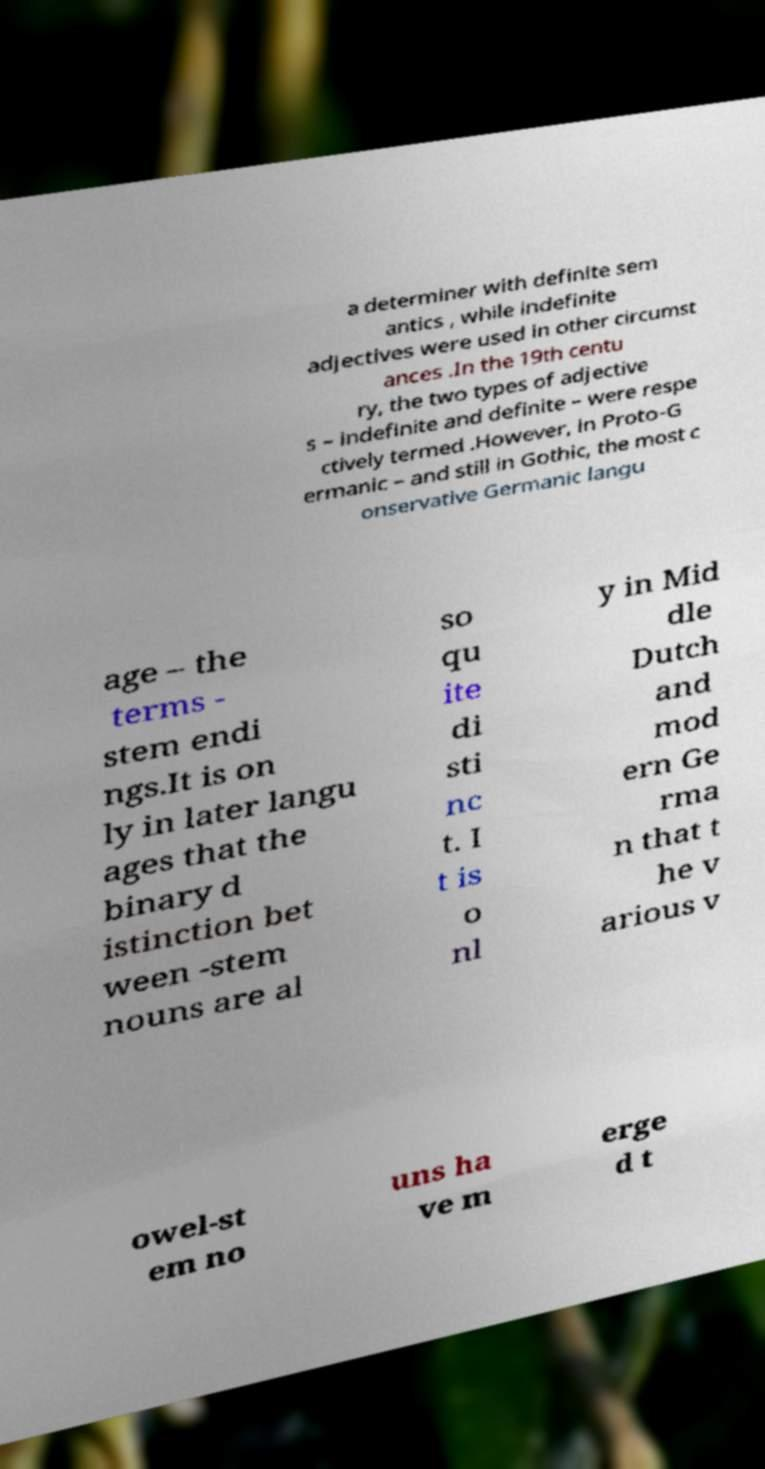For documentation purposes, I need the text within this image transcribed. Could you provide that? a determiner with definite sem antics , while indefinite adjectives were used in other circumst ances .In the 19th centu ry, the two types of adjective s – indefinite and definite – were respe ctively termed .However, in Proto-G ermanic – and still in Gothic, the most c onservative Germanic langu age – the terms - stem endi ngs.It is on ly in later langu ages that the binary d istinction bet ween -stem nouns are al so qu ite di sti nc t. I t is o nl y in Mid dle Dutch and mod ern Ge rma n that t he v arious v owel-st em no uns ha ve m erge d t 